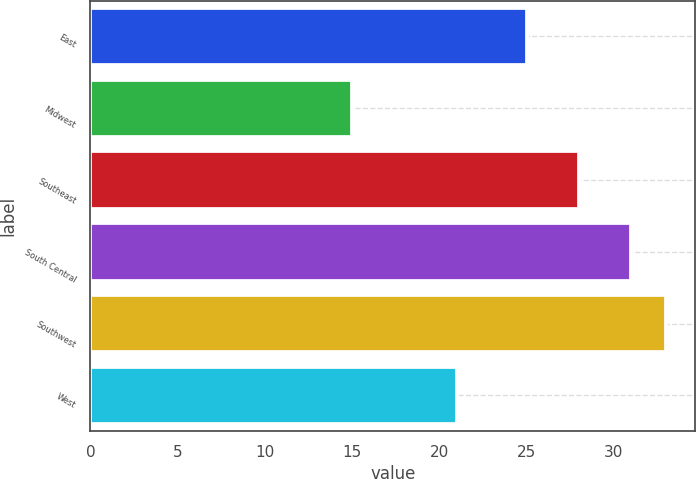Convert chart to OTSL. <chart><loc_0><loc_0><loc_500><loc_500><bar_chart><fcel>East<fcel>Midwest<fcel>Southeast<fcel>South Central<fcel>Southwest<fcel>West<nl><fcel>25<fcel>15<fcel>28<fcel>31<fcel>33<fcel>21<nl></chart> 